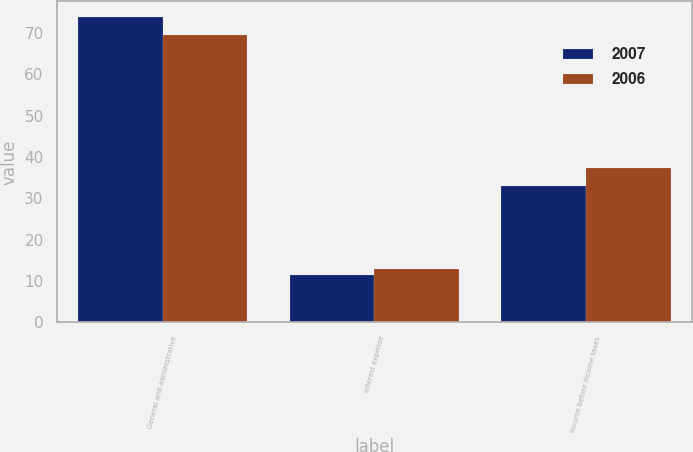<chart> <loc_0><loc_0><loc_500><loc_500><stacked_bar_chart><ecel><fcel>General and administrative<fcel>Interest expense<fcel>Income before income taxes<nl><fcel>2007<fcel>74<fcel>11.4<fcel>33.1<nl><fcel>2006<fcel>69.5<fcel>12.8<fcel>37.3<nl></chart> 